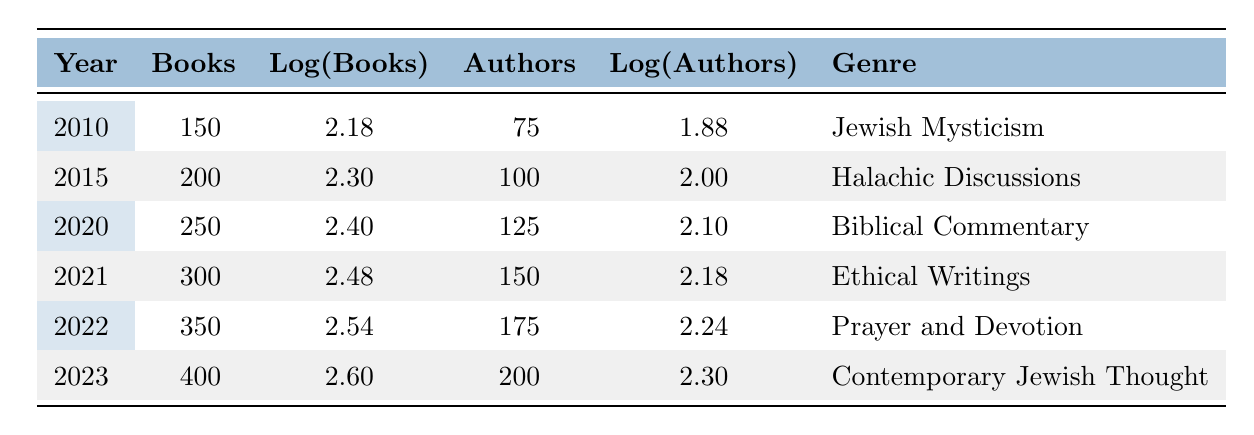What was the total number of books published from 2010 to 2023? To find the total number of books published from 2010 to 2023, we add the number of books published each year: 150 + 200 + 250 + 300 + 350 + 400 = 1650.
Answer: 1650 In which year was the most significant increase in the number of books published compared to the previous year? To determine the year with the most significant increase, we calculate the differences between the number of books published each consecutive year: 200 - 150 = 50; 250 - 200 = 50; 300 - 250 = 50; 350 - 300 = 50; 400 - 350 = 50. All years have the same increase of 50, indicating no significant difference among them.
Answer: No significant increase How many authors contributed to the books published in 2022? The table specifies that in 2022, 175 authors contributed to the published books.
Answer: 175 What is the average number of authors over the years listed in the table? The total number of authors is 75 + 100 + 125 + 150 + 175 + 200 = 925. The average is calculated by dividing the total by the number of years: 925 / 6 = 154.17.
Answer: Approximately 154 True or False: The number of authors in 2023 was greater than the number of authors in 2021. In 2021, there were 150 authors, and in 2023, there were 200 authors. Since 200 is greater than 150, the statement is true.
Answer: True What is the logarithmic value of books published in the year 2020, and how does it compare to the year 2021? The logarithmic value of books published in 2020 is 2.40, while for 2021 it is 2.48. Since 2.48 is greater than 2.40, it indicates that the logarithmic value increased from 2020 to 2021.
Answer: Increased Which genre had the highest number of books published in 2023? The genre listed for 2023 in the table is "Contemporary Jewish Thought," and it shows that 400 books were published, which is the highest number compared to previous years.
Answer: Contemporary Jewish Thought What is the percentage growth in the number of published books from 2010 to 2023? To find the percentage growth, we calculate the difference between books published in 2023 and 2010: (400 - 150) = 250. Then divide by the original amount (150) and multiply by 100: (250 / 150) * 100 = 166.67%.
Answer: Approximately 166.67% 